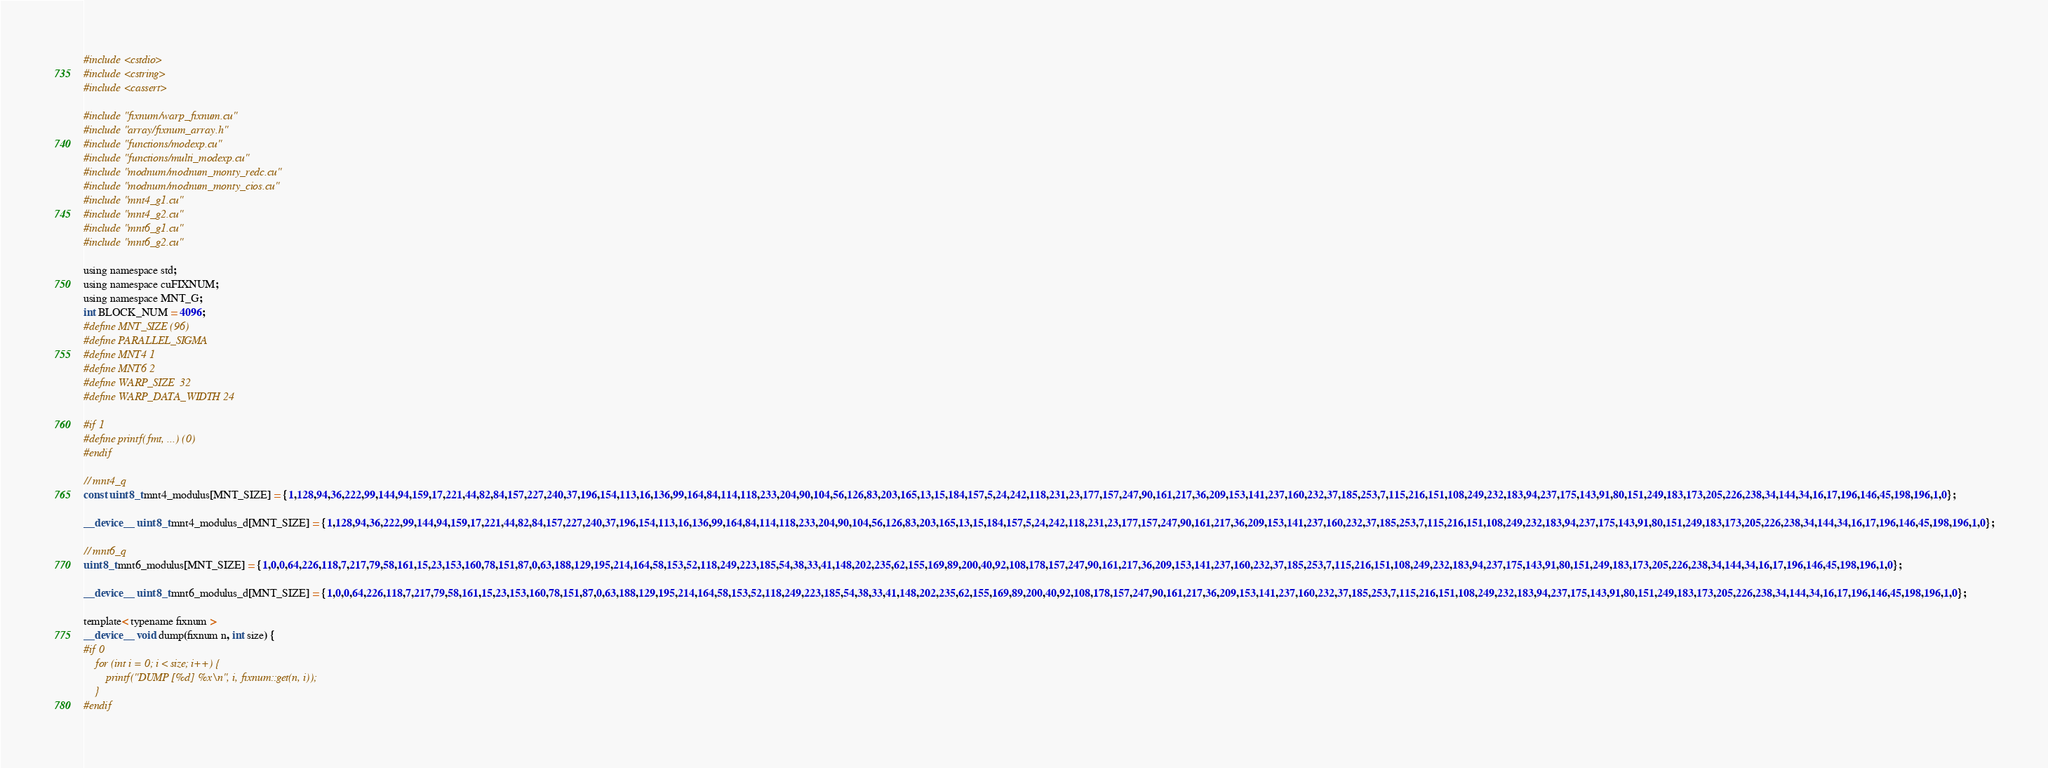<code> <loc_0><loc_0><loc_500><loc_500><_Cuda_>#include <cstdio>
#include <cstring>
#include <cassert>

#include "fixnum/warp_fixnum.cu"
#include "array/fixnum_array.h"
#include "functions/modexp.cu"
#include "functions/multi_modexp.cu"
#include "modnum/modnum_monty_redc.cu"
#include "modnum/modnum_monty_cios.cu"
#include "mnt4_g1.cu"
#include "mnt4_g2.cu"
#include "mnt6_g1.cu"
#include "mnt6_g2.cu"

using namespace std;
using namespace cuFIXNUM;
using namespace MNT_G;
int BLOCK_NUM = 4096;
#define MNT_SIZE (96)
#define PARALLEL_SIGMA
#define MNT4 1
#define MNT6 2
#define WARP_SIZE  32
#define WARP_DATA_WIDTH 24

#if 1
#define printf(fmt, ...) (0)
#endif

// mnt4_q
const uint8_t mnt4_modulus[MNT_SIZE] = {1,128,94,36,222,99,144,94,159,17,221,44,82,84,157,227,240,37,196,154,113,16,136,99,164,84,114,118,233,204,90,104,56,126,83,203,165,13,15,184,157,5,24,242,118,231,23,177,157,247,90,161,217,36,209,153,141,237,160,232,37,185,253,7,115,216,151,108,249,232,183,94,237,175,143,91,80,151,249,183,173,205,226,238,34,144,34,16,17,196,146,45,198,196,1,0};

__device__ uint8_t mnt4_modulus_d[MNT_SIZE] = {1,128,94,36,222,99,144,94,159,17,221,44,82,84,157,227,240,37,196,154,113,16,136,99,164,84,114,118,233,204,90,104,56,126,83,203,165,13,15,184,157,5,24,242,118,231,23,177,157,247,90,161,217,36,209,153,141,237,160,232,37,185,253,7,115,216,151,108,249,232,183,94,237,175,143,91,80,151,249,183,173,205,226,238,34,144,34,16,17,196,146,45,198,196,1,0};

// mnt6_q
uint8_t mnt6_modulus[MNT_SIZE] = {1,0,0,64,226,118,7,217,79,58,161,15,23,153,160,78,151,87,0,63,188,129,195,214,164,58,153,52,118,249,223,185,54,38,33,41,148,202,235,62,155,169,89,200,40,92,108,178,157,247,90,161,217,36,209,153,141,237,160,232,37,185,253,7,115,216,151,108,249,232,183,94,237,175,143,91,80,151,249,183,173,205,226,238,34,144,34,16,17,196,146,45,198,196,1,0};

__device__ uint8_t mnt6_modulus_d[MNT_SIZE] = {1,0,0,64,226,118,7,217,79,58,161,15,23,153,160,78,151,87,0,63,188,129,195,214,164,58,153,52,118,249,223,185,54,38,33,41,148,202,235,62,155,169,89,200,40,92,108,178,157,247,90,161,217,36,209,153,141,237,160,232,37,185,253,7,115,216,151,108,249,232,183,94,237,175,143,91,80,151,249,183,173,205,226,238,34,144,34,16,17,196,146,45,198,196,1,0};

template< typename fixnum >
__device__ void dump(fixnum n, int size) {
#if 0
	for (int i = 0; i < size; i++) {
		printf("DUMP [%d] %x\n", i, fixnum::get(n, i));
	}
#endif</code> 